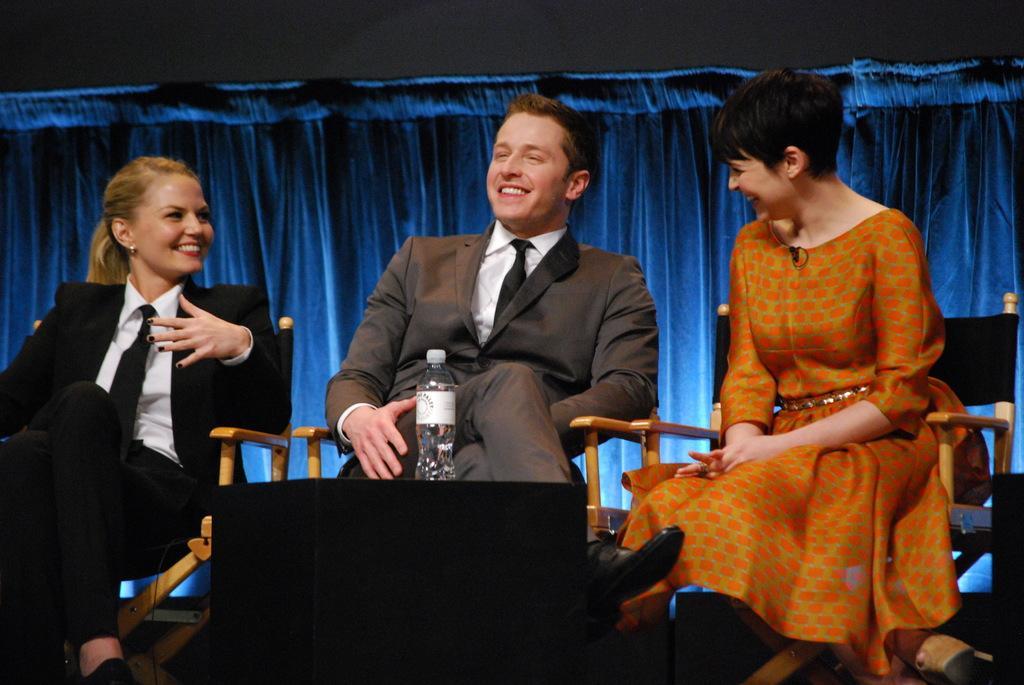Can you describe this image briefly? In this image I can see some people are sitting on the chairs. I can see a bottle. In the background, I can see a blue cloth. 